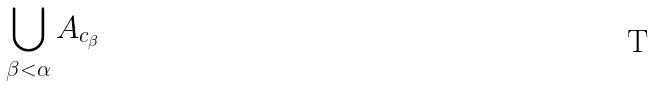<formula> <loc_0><loc_0><loc_500><loc_500>\bigcup _ { \beta < \alpha } A _ { c _ { \beta } }</formula> 